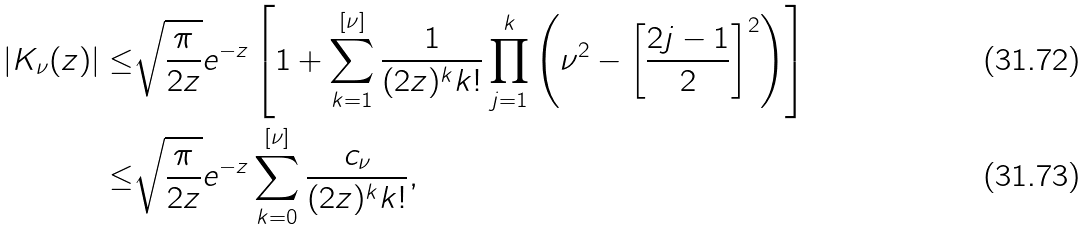<formula> <loc_0><loc_0><loc_500><loc_500>| K _ { \nu } ( z ) | \leq & \sqrt { \frac { \pi } { 2 z } } e ^ { - z } \left [ 1 + \sum _ { k = 1 } ^ { [ \nu ] } \frac { 1 } { ( 2 z ) ^ { k } k ! } \prod _ { j = 1 } ^ { k } \left ( \nu ^ { 2 } - \left [ \frac { 2 j - 1 } { 2 } \right ] ^ { 2 } \right ) \right ] \\ \leq & \sqrt { \frac { \pi } { 2 z } } e ^ { - z } \sum _ { k = 0 } ^ { [ \nu ] } \frac { c _ { \nu } } { ( 2 z ) ^ { k } k ! } ,</formula> 